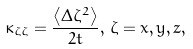Convert formula to latex. <formula><loc_0><loc_0><loc_500><loc_500>\kappa _ { \zeta \zeta } = \frac { \left < \Delta \zeta ^ { 2 } \right > } { 2 t } , \, \zeta = x , y , z ,</formula> 